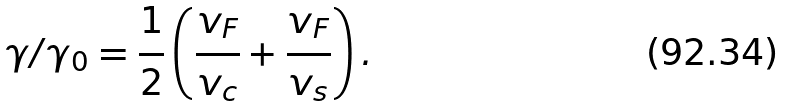<formula> <loc_0><loc_0><loc_500><loc_500>\gamma / \gamma _ { 0 } = \frac { 1 } { 2 } \left ( \frac { v _ { F } } { v _ { c } } + \frac { v _ { F } } { v _ { s } } \right ) .</formula> 